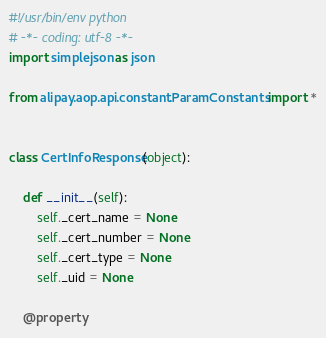Convert code to text. <code><loc_0><loc_0><loc_500><loc_500><_Python_>#!/usr/bin/env python
# -*- coding: utf-8 -*-
import simplejson as json

from alipay.aop.api.constant.ParamConstants import *


class CertInfoResponse(object):

    def __init__(self):
        self._cert_name = None
        self._cert_number = None
        self._cert_type = None
        self._uid = None

    @property</code> 